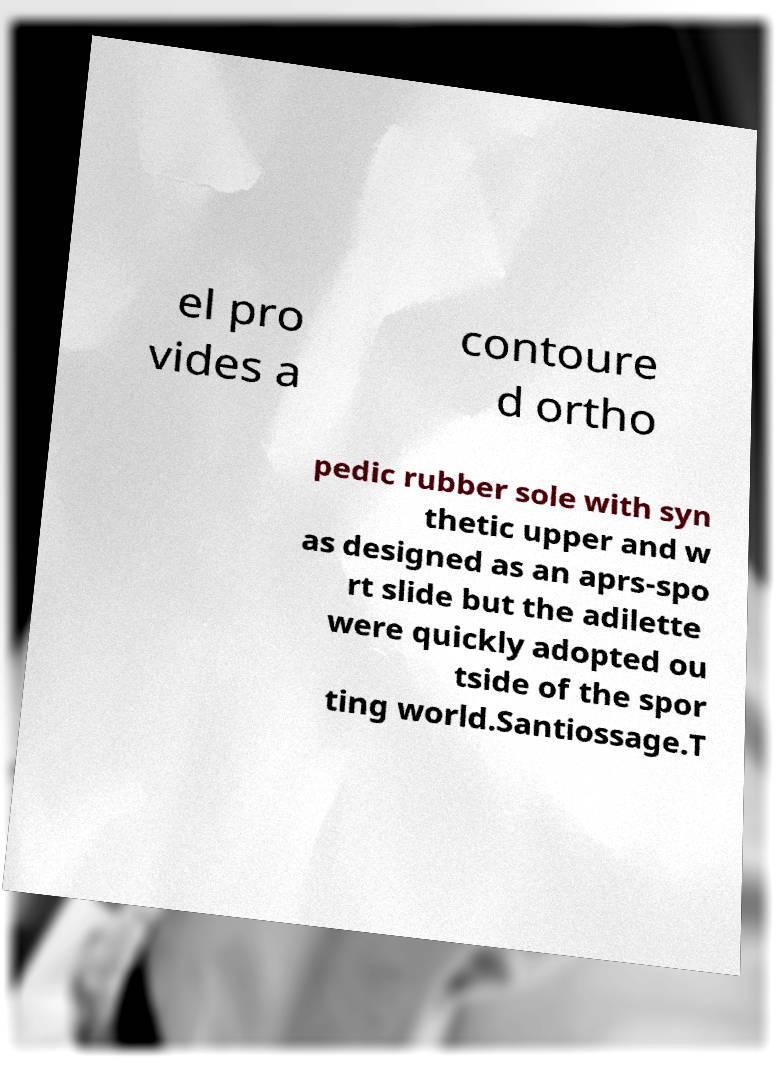Could you assist in decoding the text presented in this image and type it out clearly? el pro vides a contoure d ortho pedic rubber sole with syn thetic upper and w as designed as an aprs-spo rt slide but the adilette were quickly adopted ou tside of the spor ting world.Santiossage.T 